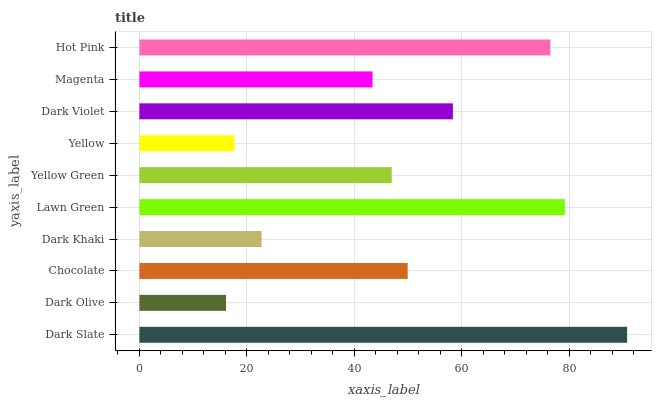Is Dark Olive the minimum?
Answer yes or no. Yes. Is Dark Slate the maximum?
Answer yes or no. Yes. Is Chocolate the minimum?
Answer yes or no. No. Is Chocolate the maximum?
Answer yes or no. No. Is Chocolate greater than Dark Olive?
Answer yes or no. Yes. Is Dark Olive less than Chocolate?
Answer yes or no. Yes. Is Dark Olive greater than Chocolate?
Answer yes or no. No. Is Chocolate less than Dark Olive?
Answer yes or no. No. Is Chocolate the high median?
Answer yes or no. Yes. Is Yellow Green the low median?
Answer yes or no. Yes. Is Lawn Green the high median?
Answer yes or no. No. Is Dark Olive the low median?
Answer yes or no. No. 